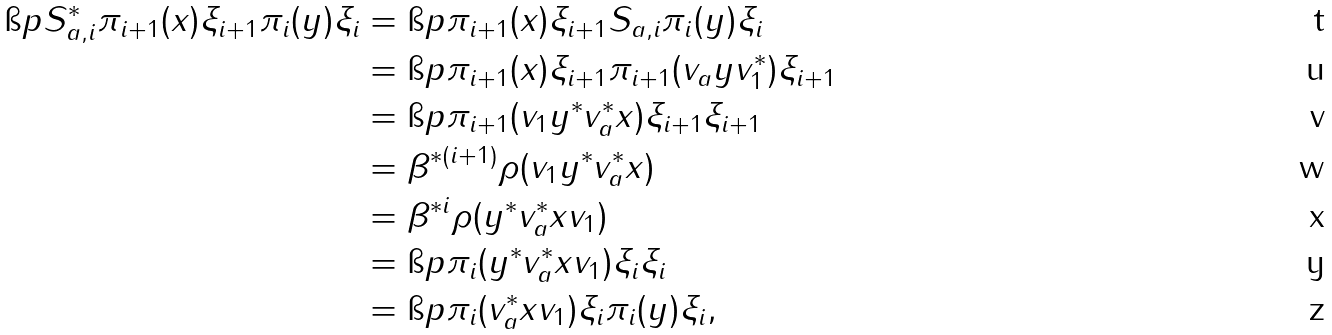Convert formula to latex. <formula><loc_0><loc_0><loc_500><loc_500>\i p { S _ { a , i } ^ { * } \pi _ { i + 1 } ( x ) \xi _ { i + 1 } } { \pi _ { i } ( y ) \xi _ { i } } & = \i p { \pi _ { i + 1 } ( x ) \xi _ { i + 1 } } { S _ { a , i } \pi _ { i } ( y ) \xi _ { i } } \\ & = \i p { \pi _ { i + 1 } ( x ) \xi _ { i + 1 } } { \pi _ { i + 1 } ( v _ { a } y v _ { 1 } ^ { * } ) \xi _ { i + 1 } } \\ & = \i p { \pi _ { i + 1 } ( v _ { 1 } y ^ { * } v _ { a } ^ { * } x ) \xi _ { i + 1 } } { \xi _ { i + 1 } } \\ & = \beta ^ { * ( i + 1 ) } \rho ( v _ { 1 } y ^ { * } v _ { a } ^ { * } x ) \\ & = \beta ^ { * i } \rho ( y ^ { * } v _ { a } ^ { * } x v _ { 1 } ) \\ & = \i p { \pi _ { i } ( y ^ { * } v _ { a } ^ { * } x v _ { 1 } ) \xi _ { i } } { \xi _ { i } } \\ & = \i p { \pi _ { i } ( v _ { a } ^ { * } x v _ { 1 } ) \xi _ { i } } { \pi _ { i } ( y ) \xi _ { i } } ,</formula> 